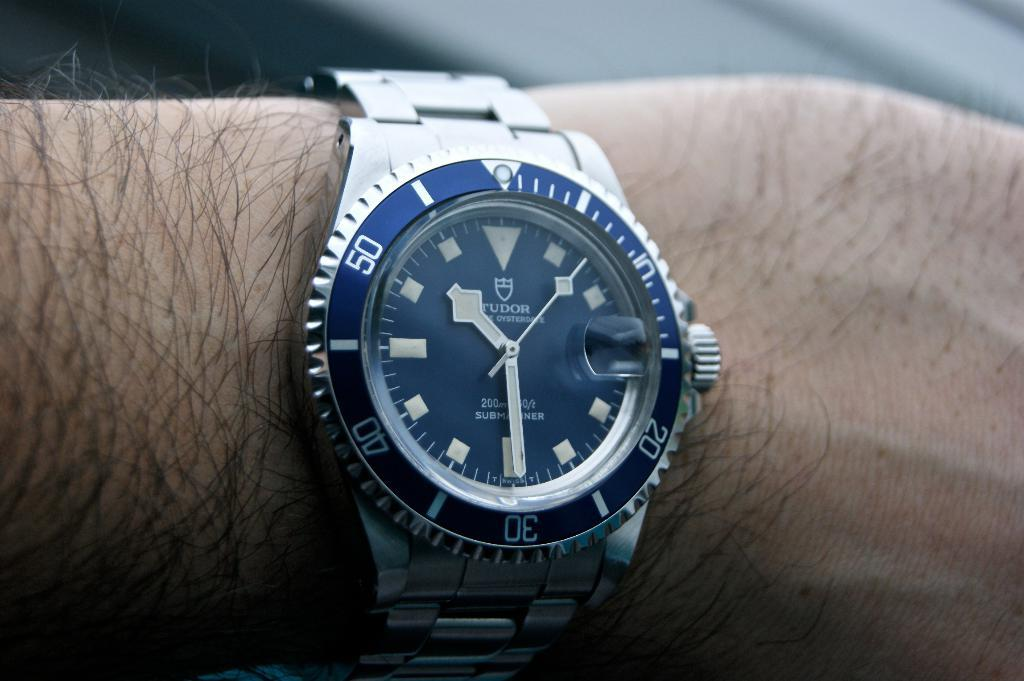<image>
Offer a succinct explanation of the picture presented. A Tudor brand watch is silver and on a wrist. 